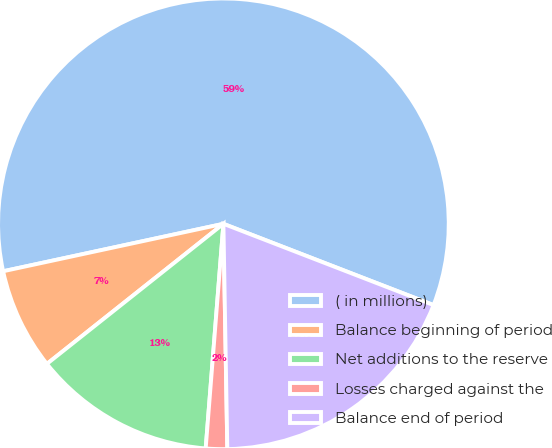<chart> <loc_0><loc_0><loc_500><loc_500><pie_chart><fcel>( in millions)<fcel>Balance beginning of period<fcel>Net additions to the reserve<fcel>Losses charged against the<fcel>Balance end of period<nl><fcel>59.25%<fcel>7.3%<fcel>13.07%<fcel>1.53%<fcel>18.85%<nl></chart> 